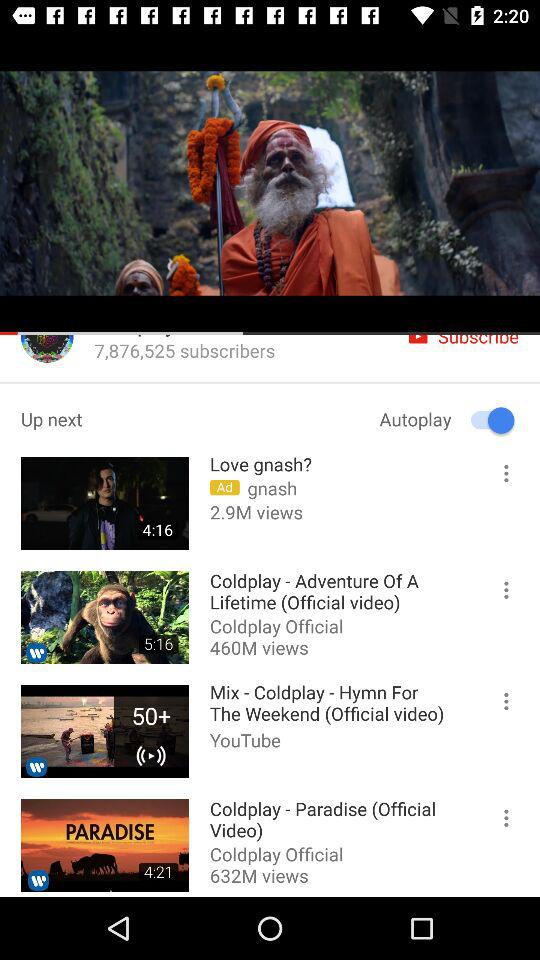What is the total number of subscribers? The total number of subscribers is 7,876,525. 